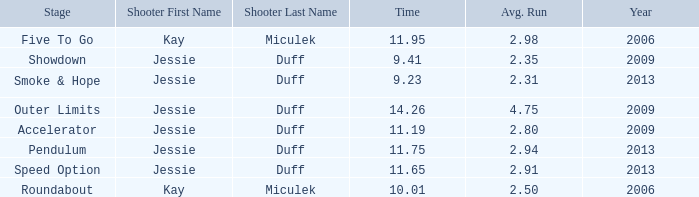What is the total amount of time for years prior to 2013 when speed option is the stage? None. 